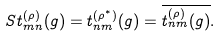<formula> <loc_0><loc_0><loc_500><loc_500>S t _ { m n } ^ { ( \rho ) } ( g ) = t _ { n m } ^ { ( \rho ^ { \ast } ) } ( g ) = \overline { t _ { n m } ^ { ( \rho ) } ( g ) } .</formula> 